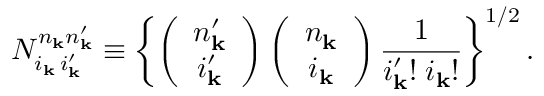<formula> <loc_0><loc_0><loc_500><loc_500>N _ { i _ { k } \, i _ { k } ^ { \prime } } ^ { n _ { k } n _ { k } ^ { \prime } } \equiv \left \{ \left ( \begin{array} { c } { { { n _ { k } ^ { \prime } } } } \\ { { { i _ { k } ^ { \prime } } } } \end{array} \right ) \left ( \begin{array} { c } { { n _ { k } } } \\ { { i _ { k } } } \end{array} \right ) \frac { 1 } { i _ { k } ^ { \prime } ! \, i _ { k } ! } \right \} ^ { 1 / 2 } .</formula> 